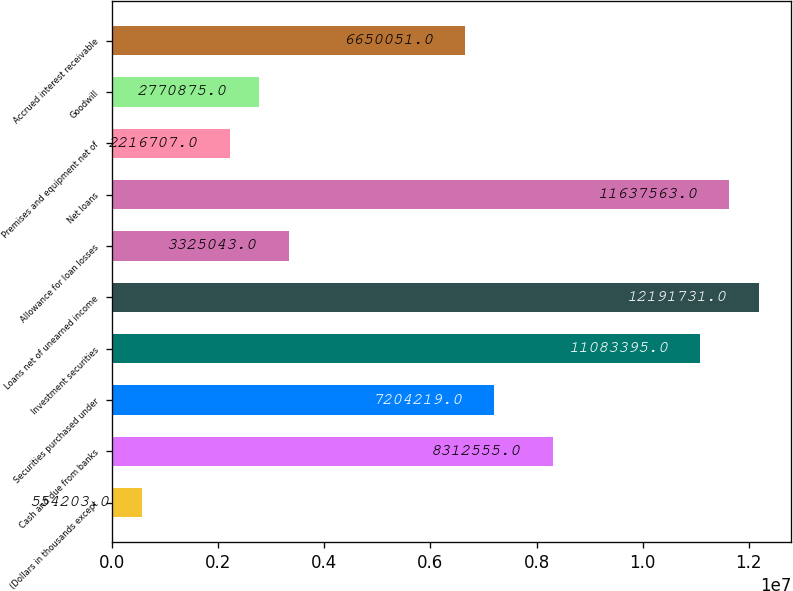Convert chart. <chart><loc_0><loc_0><loc_500><loc_500><bar_chart><fcel>(Dollars in thousands except<fcel>Cash and due from banks<fcel>Securities purchased under<fcel>Investment securities<fcel>Loans net of unearned income<fcel>Allowance for loan losses<fcel>Net loans<fcel>Premises and equipment net of<fcel>Goodwill<fcel>Accrued interest receivable<nl><fcel>554203<fcel>8.31256e+06<fcel>7.20422e+06<fcel>1.10834e+07<fcel>1.21917e+07<fcel>3.32504e+06<fcel>1.16376e+07<fcel>2.21671e+06<fcel>2.77088e+06<fcel>6.65005e+06<nl></chart> 